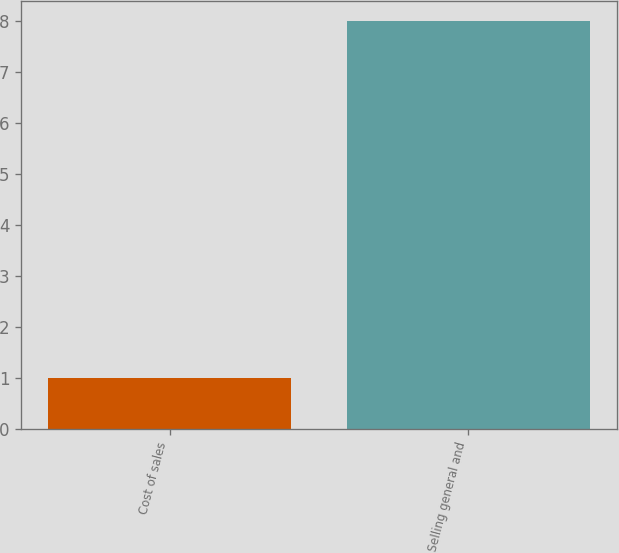Convert chart. <chart><loc_0><loc_0><loc_500><loc_500><bar_chart><fcel>Cost of sales<fcel>Selling general and<nl><fcel>1<fcel>8<nl></chart> 